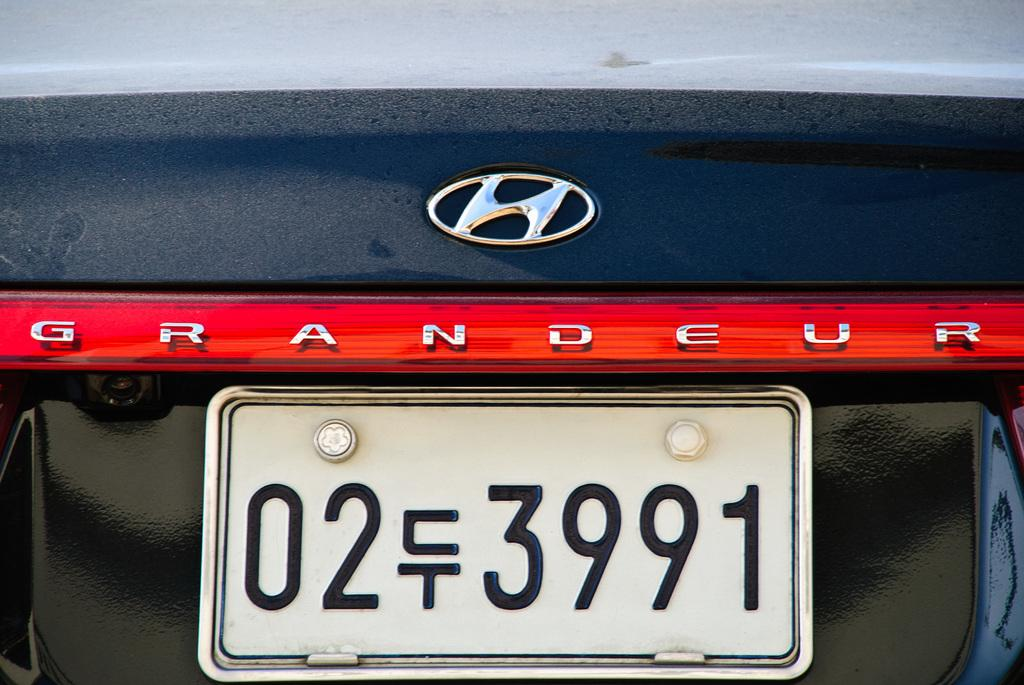<image>
Describe the image concisely. A hundai Grandeur car with the license plate 